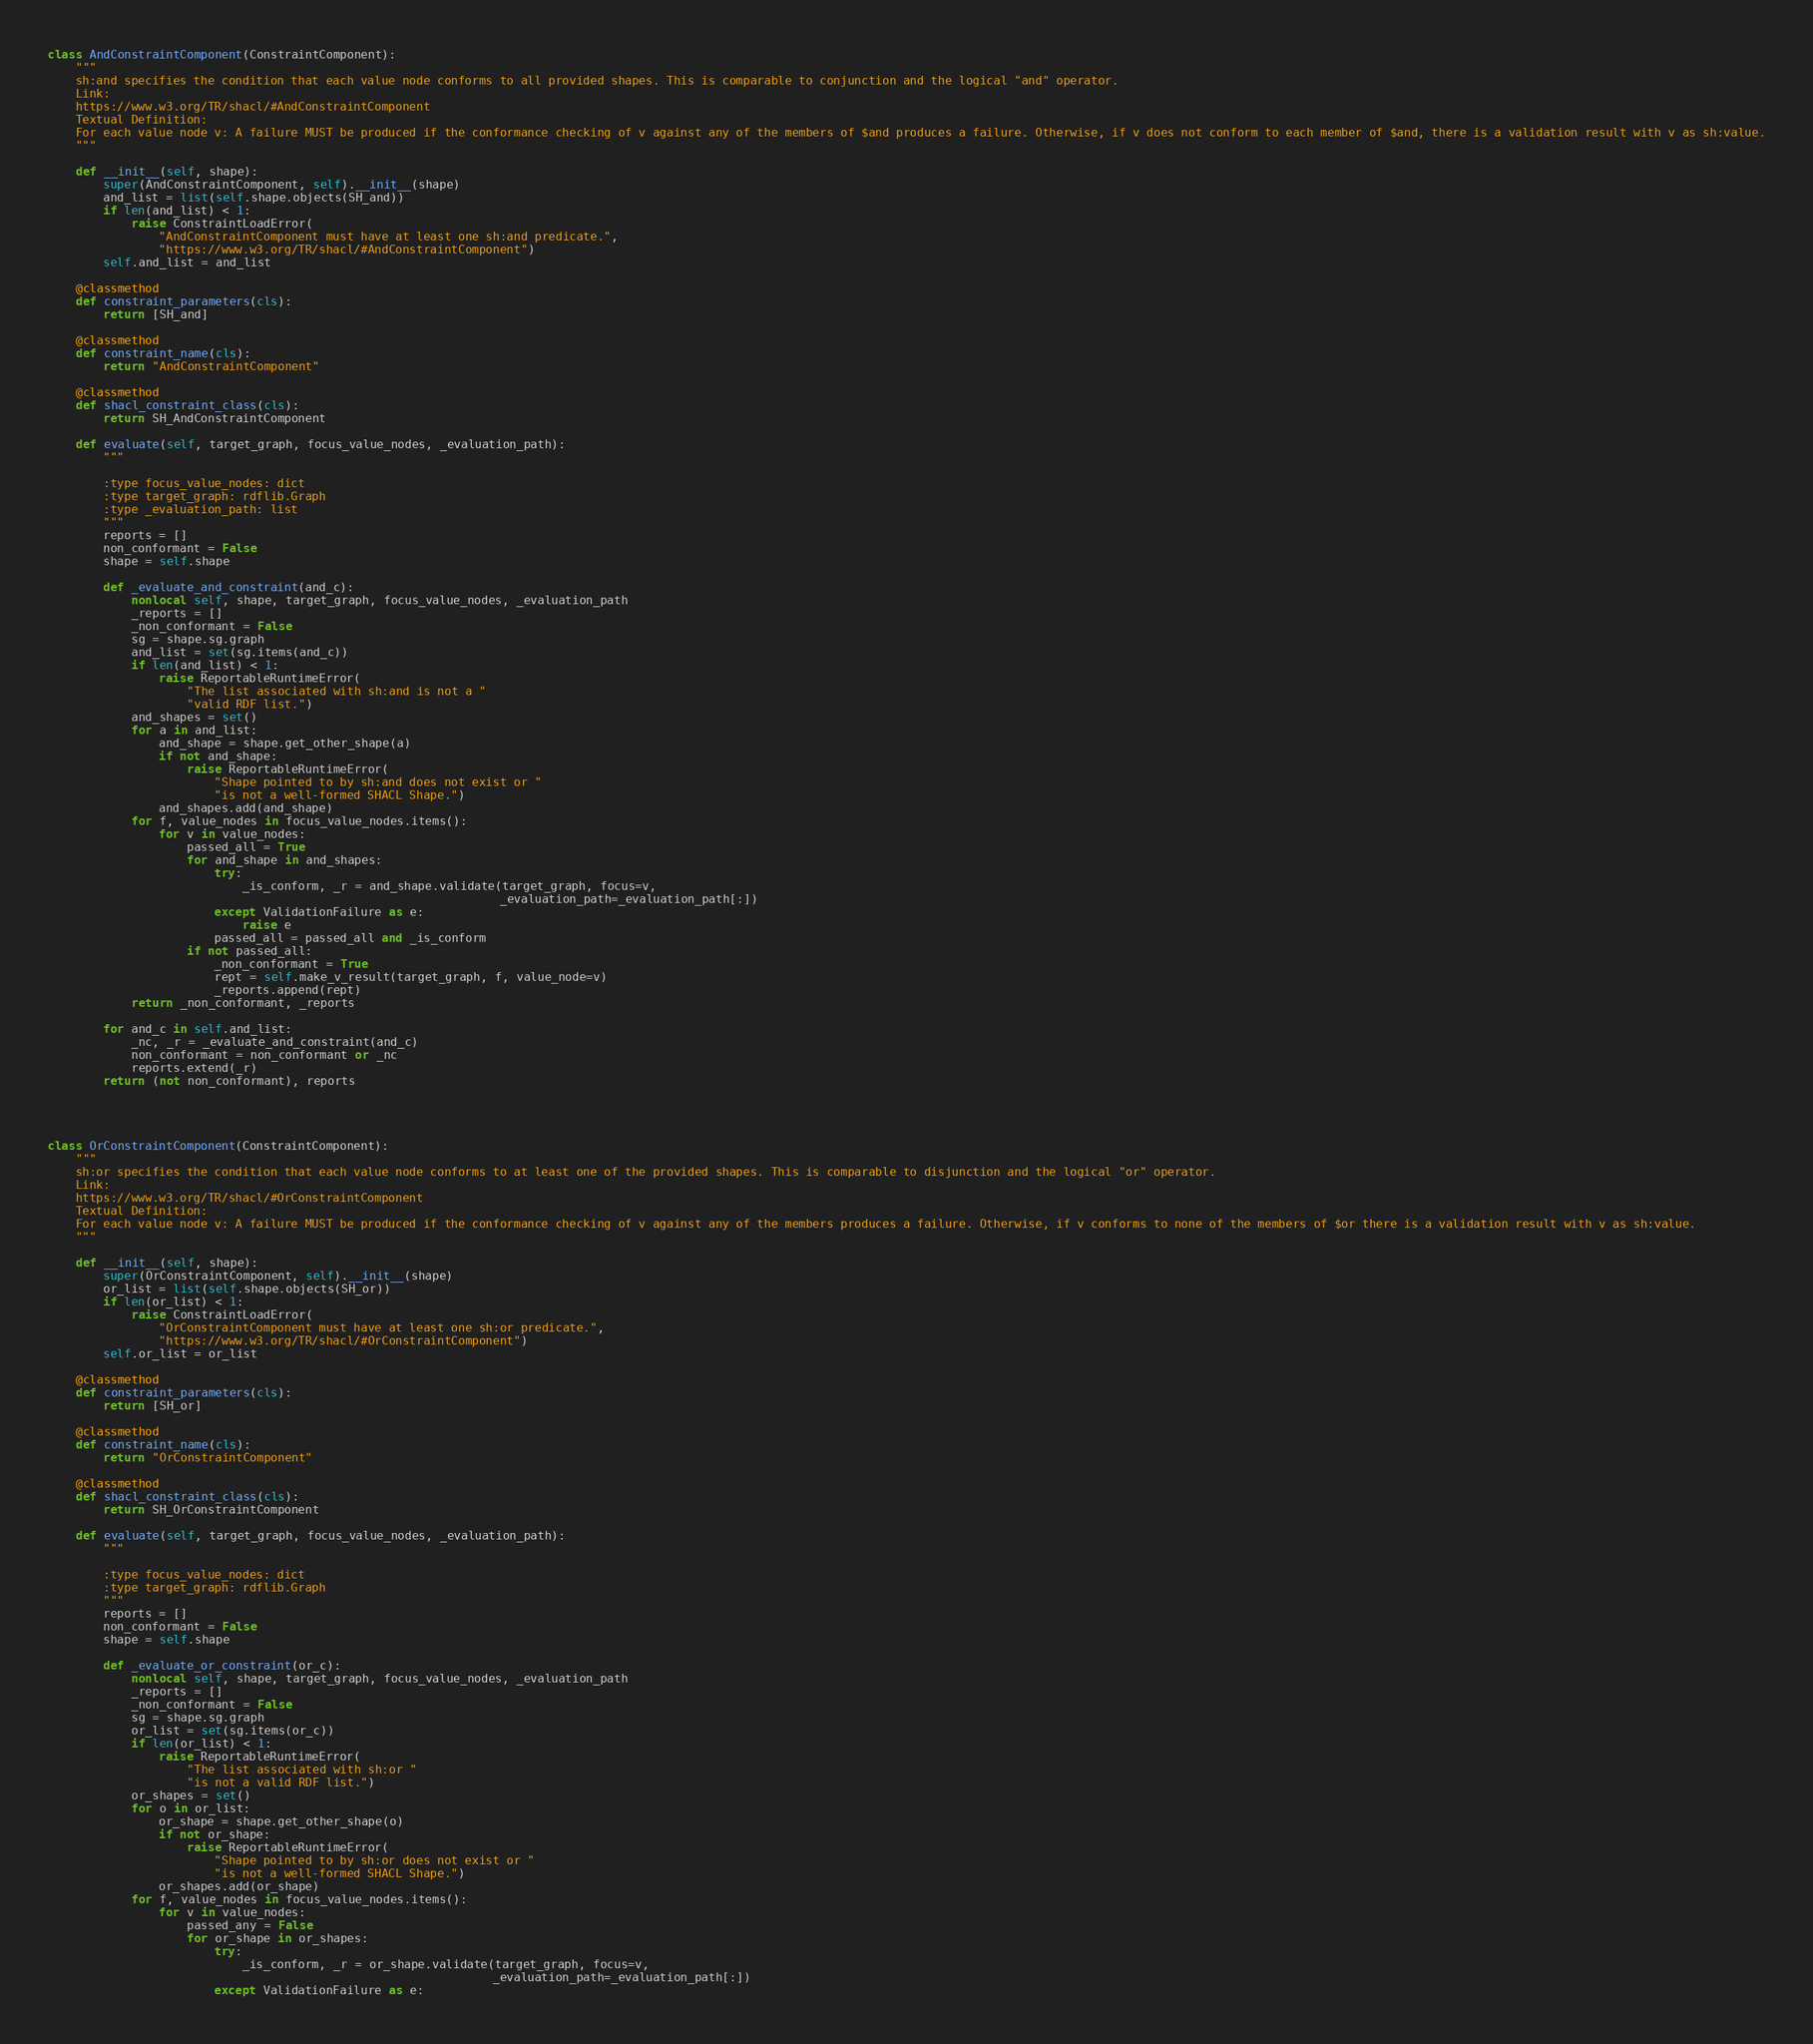Convert code to text. <code><loc_0><loc_0><loc_500><loc_500><_Python_>
class AndConstraintComponent(ConstraintComponent):
    """
    sh:and specifies the condition that each value node conforms to all provided shapes. This is comparable to conjunction and the logical "and" operator.
    Link:
    https://www.w3.org/TR/shacl/#AndConstraintComponent
    Textual Definition:
    For each value node v: A failure MUST be produced if the conformance checking of v against any of the members of $and produces a failure. Otherwise, if v does not conform to each member of $and, there is a validation result with v as sh:value.
    """

    def __init__(self, shape):
        super(AndConstraintComponent, self).__init__(shape)
        and_list = list(self.shape.objects(SH_and))
        if len(and_list) < 1:
            raise ConstraintLoadError(
                "AndConstraintComponent must have at least one sh:and predicate.",
                "https://www.w3.org/TR/shacl/#AndConstraintComponent")
        self.and_list = and_list

    @classmethod
    def constraint_parameters(cls):
        return [SH_and]

    @classmethod
    def constraint_name(cls):
        return "AndConstraintComponent"

    @classmethod
    def shacl_constraint_class(cls):
        return SH_AndConstraintComponent

    def evaluate(self, target_graph, focus_value_nodes, _evaluation_path):
        """

        :type focus_value_nodes: dict
        :type target_graph: rdflib.Graph
        :type _evaluation_path: list
        """
        reports = []
        non_conformant = False
        shape = self.shape

        def _evaluate_and_constraint(and_c):
            nonlocal self, shape, target_graph, focus_value_nodes, _evaluation_path
            _reports = []
            _non_conformant = False
            sg = shape.sg.graph
            and_list = set(sg.items(and_c))
            if len(and_list) < 1:
                raise ReportableRuntimeError(
                    "The list associated with sh:and is not a "
                    "valid RDF list.")
            and_shapes = set()
            for a in and_list:
                and_shape = shape.get_other_shape(a)
                if not and_shape:
                    raise ReportableRuntimeError(
                        "Shape pointed to by sh:and does not exist or "
                        "is not a well-formed SHACL Shape.")
                and_shapes.add(and_shape)
            for f, value_nodes in focus_value_nodes.items():
                for v in value_nodes:
                    passed_all = True
                    for and_shape in and_shapes:
                        try:
                            _is_conform, _r = and_shape.validate(target_graph, focus=v,
                                                                 _evaluation_path=_evaluation_path[:])
                        except ValidationFailure as e:
                            raise e
                        passed_all = passed_all and _is_conform
                    if not passed_all:
                        _non_conformant = True
                        rept = self.make_v_result(target_graph, f, value_node=v)
                        _reports.append(rept)
            return _non_conformant, _reports

        for and_c in self.and_list:
            _nc, _r = _evaluate_and_constraint(and_c)
            non_conformant = non_conformant or _nc
            reports.extend(_r)
        return (not non_conformant), reports




class OrConstraintComponent(ConstraintComponent):
    """
    sh:or specifies the condition that each value node conforms to at least one of the provided shapes. This is comparable to disjunction and the logical "or" operator.
    Link:
    https://www.w3.org/TR/shacl/#OrConstraintComponent
    Textual Definition:
    For each value node v: A failure MUST be produced if the conformance checking of v against any of the members produces a failure. Otherwise, if v conforms to none of the members of $or there is a validation result with v as sh:value.
    """

    def __init__(self, shape):
        super(OrConstraintComponent, self).__init__(shape)
        or_list = list(self.shape.objects(SH_or))
        if len(or_list) < 1:
            raise ConstraintLoadError(
                "OrConstraintComponent must have at least one sh:or predicate.",
                "https://www.w3.org/TR/shacl/#OrConstraintComponent")
        self.or_list = or_list

    @classmethod
    def constraint_parameters(cls):
        return [SH_or]

    @classmethod
    def constraint_name(cls):
        return "OrConstraintComponent"

    @classmethod
    def shacl_constraint_class(cls):
        return SH_OrConstraintComponent

    def evaluate(self, target_graph, focus_value_nodes, _evaluation_path):
        """

        :type focus_value_nodes: dict
        :type target_graph: rdflib.Graph
        """
        reports = []
        non_conformant = False
        shape = self.shape

        def _evaluate_or_constraint(or_c):
            nonlocal self, shape, target_graph, focus_value_nodes, _evaluation_path
            _reports = []
            _non_conformant = False
            sg = shape.sg.graph
            or_list = set(sg.items(or_c))
            if len(or_list) < 1:
                raise ReportableRuntimeError(
                    "The list associated with sh:or "
                    "is not a valid RDF list.")
            or_shapes = set()
            for o in or_list:
                or_shape = shape.get_other_shape(o)
                if not or_shape:
                    raise ReportableRuntimeError(
                        "Shape pointed to by sh:or does not exist or "
                        "is not a well-formed SHACL Shape.")
                or_shapes.add(or_shape)
            for f, value_nodes in focus_value_nodes.items():
                for v in value_nodes:
                    passed_any = False
                    for or_shape in or_shapes:
                        try:
                            _is_conform, _r = or_shape.validate(target_graph, focus=v,
                                                                _evaluation_path=_evaluation_path[:])
                        except ValidationFailure as e:</code> 